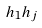<formula> <loc_0><loc_0><loc_500><loc_500>h _ { 1 } h _ { j }</formula> 